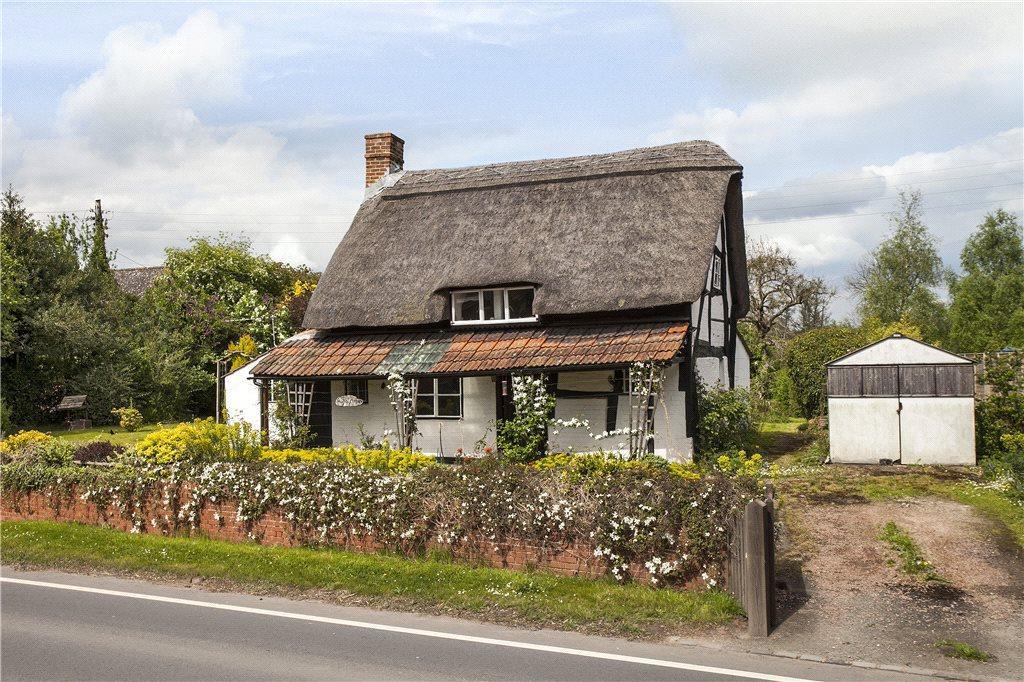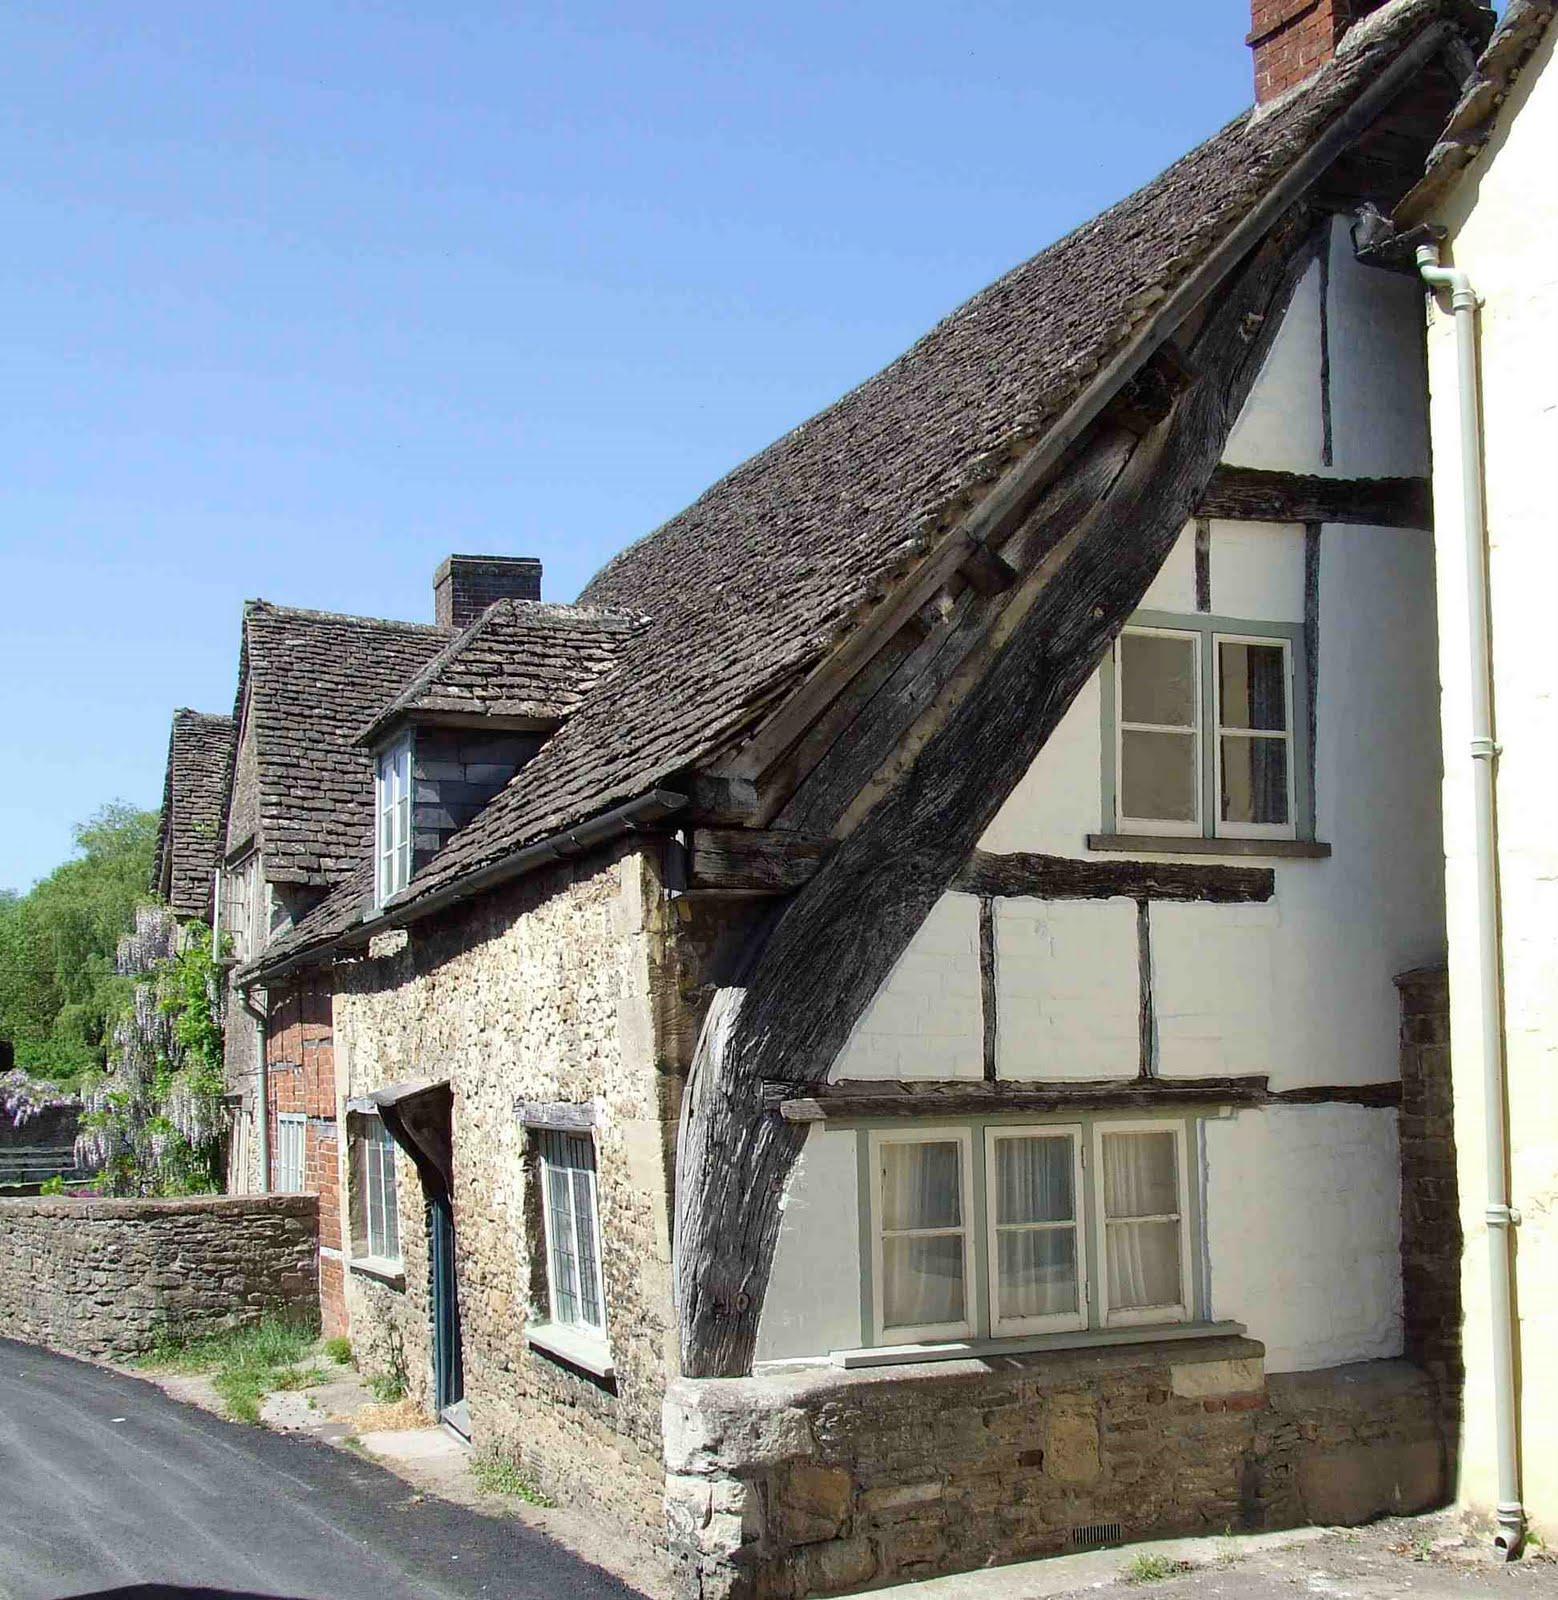The first image is the image on the left, the second image is the image on the right. Assess this claim about the two images: "The left image shows the front of a white house with bold dark lines on it forming geometric patterns, a chimney on the left end, and a thick gray peaked roof with at least one notched cut-out for windows.". Correct or not? Answer yes or no. Yes. The first image is the image on the left, the second image is the image on the right. Evaluate the accuracy of this statement regarding the images: "There is a fence bordering the house in one of the images.". Is it true? Answer yes or no. Yes. 